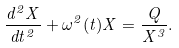<formula> <loc_0><loc_0><loc_500><loc_500>\frac { d ^ { 2 } X } { d t ^ { 2 } } + \omega ^ { 2 } ( t ) X = \frac { Q } { X ^ { 3 } } .</formula> 